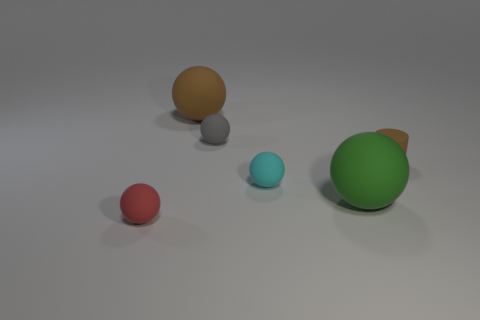There is a rubber sphere behind the small gray matte ball; is it the same size as the ball that is right of the tiny cyan object?
Offer a very short reply. Yes. What number of small objects are on the right side of the tiny cyan ball and on the left side of the tiny brown rubber cylinder?
Make the answer very short. 0. The other large matte thing that is the same shape as the big green object is what color?
Your response must be concise. Brown. Are there fewer small red matte things than big yellow metallic cubes?
Offer a very short reply. No. There is a brown matte cylinder; does it have the same size as the brown object that is behind the tiny brown rubber object?
Provide a succinct answer. No. What color is the tiny rubber sphere to the right of the tiny matte sphere behind the brown cylinder?
Keep it short and to the point. Cyan. What number of objects are balls that are in front of the cyan matte thing or rubber objects that are on the right side of the small red thing?
Your answer should be compact. 6. Do the green rubber object and the red matte object have the same size?
Your answer should be compact. No. Is the shape of the tiny thing that is to the left of the big brown sphere the same as the big object behind the tiny cyan object?
Provide a succinct answer. Yes. How big is the cyan rubber ball?
Offer a terse response. Small. 